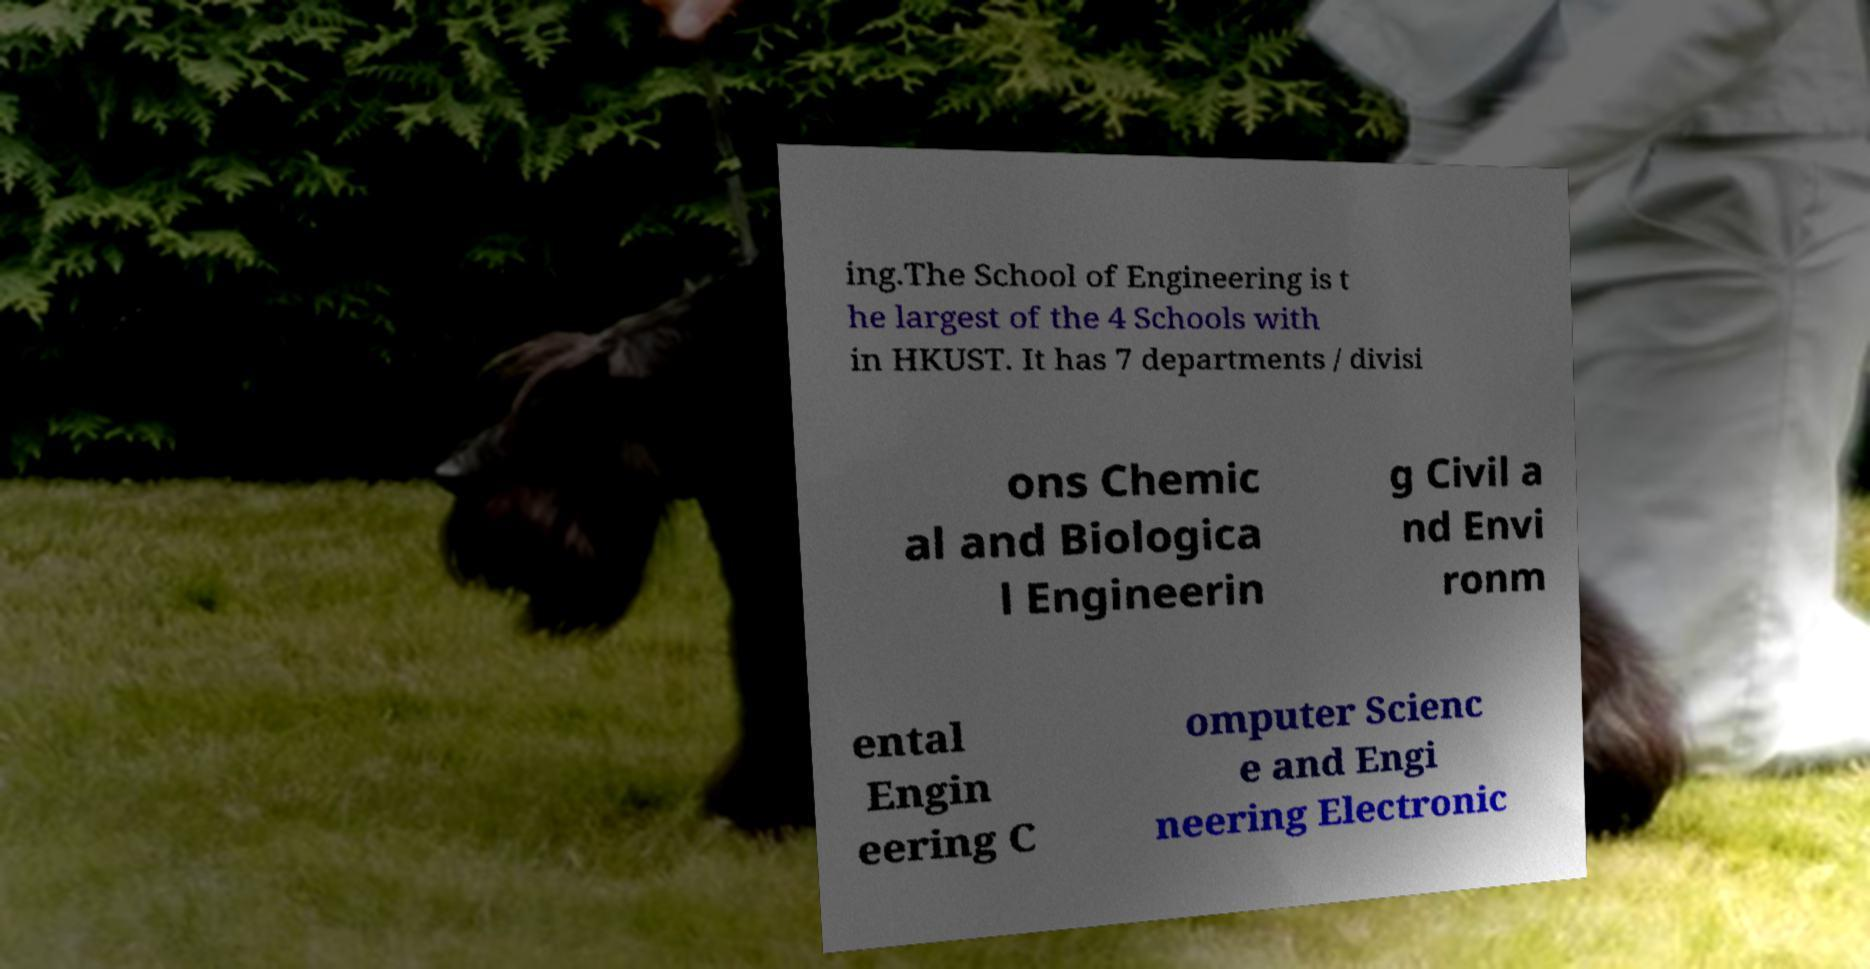There's text embedded in this image that I need extracted. Can you transcribe it verbatim? ing.The School of Engineering is t he largest of the 4 Schools with in HKUST. It has 7 departments / divisi ons Chemic al and Biologica l Engineerin g Civil a nd Envi ronm ental Engin eering C omputer Scienc e and Engi neering Electronic 